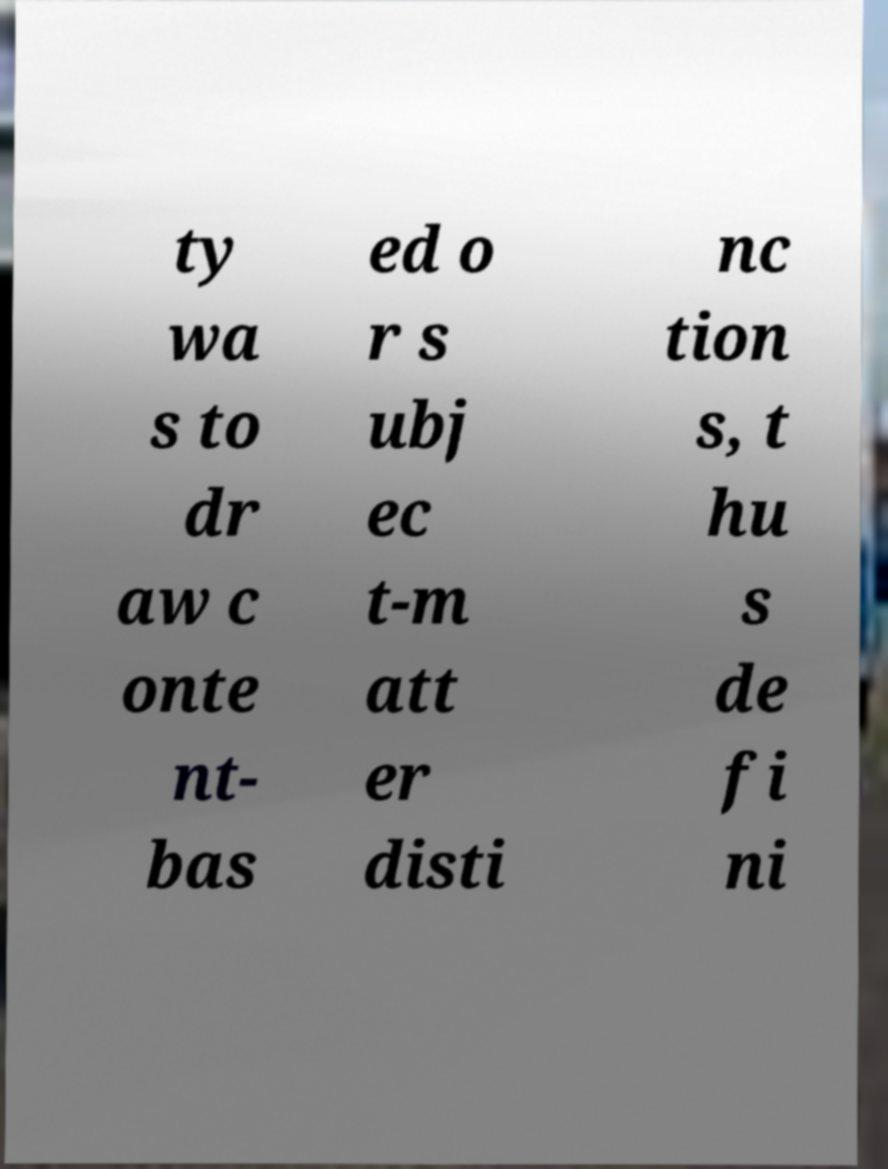For documentation purposes, I need the text within this image transcribed. Could you provide that? ty wa s to dr aw c onte nt- bas ed o r s ubj ec t-m att er disti nc tion s, t hu s de fi ni 